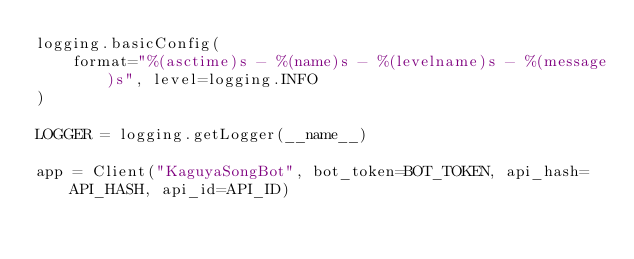Convert code to text. <code><loc_0><loc_0><loc_500><loc_500><_Python_>logging.basicConfig(
    format="%(asctime)s - %(name)s - %(levelname)s - %(message)s", level=logging.INFO
)

LOGGER = logging.getLogger(__name__)

app = Client("KaguyaSongBot", bot_token=BOT_TOKEN, api_hash=API_HASH, api_id=API_ID)
</code> 